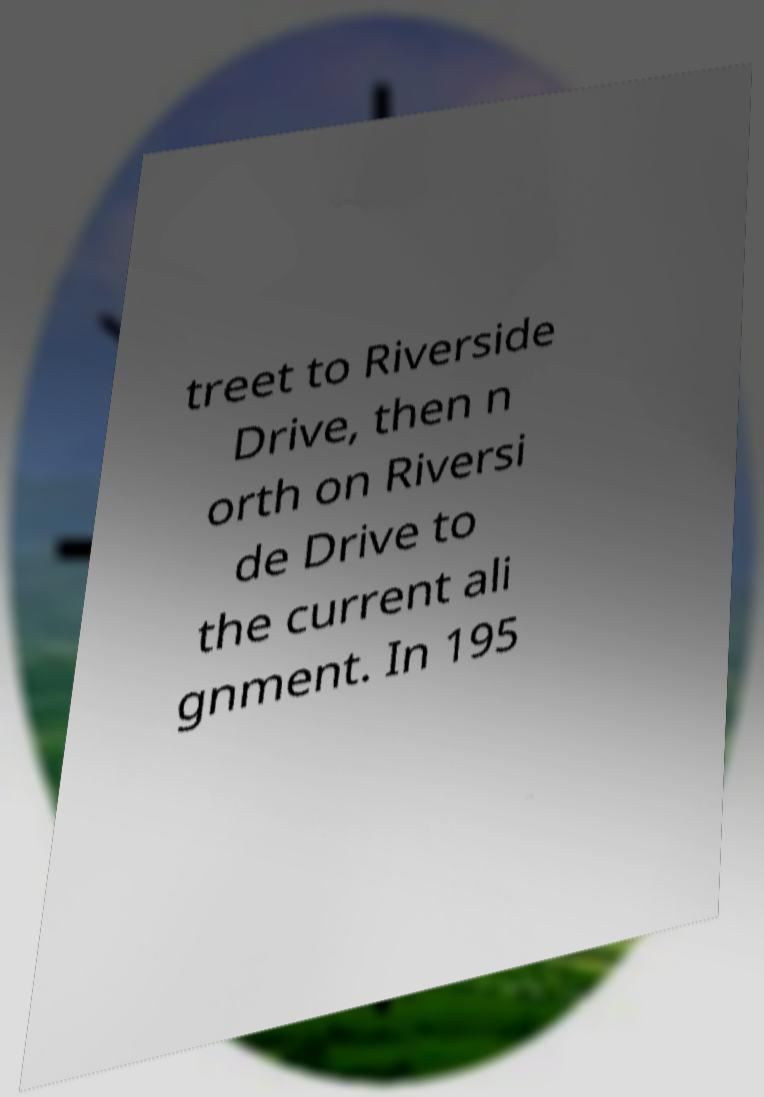Please read and relay the text visible in this image. What does it say? treet to Riverside Drive, then n orth on Riversi de Drive to the current ali gnment. In 195 